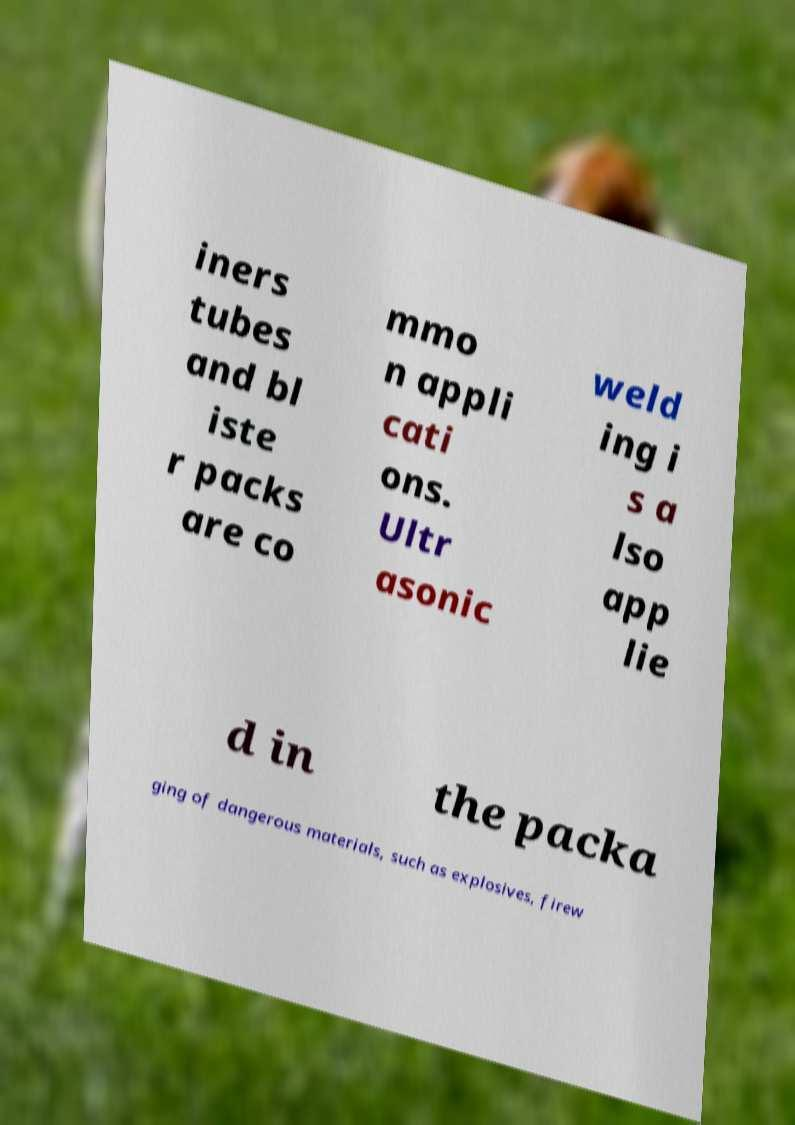Can you accurately transcribe the text from the provided image for me? iners tubes and bl iste r packs are co mmo n appli cati ons. Ultr asonic weld ing i s a lso app lie d in the packa ging of dangerous materials, such as explosives, firew 